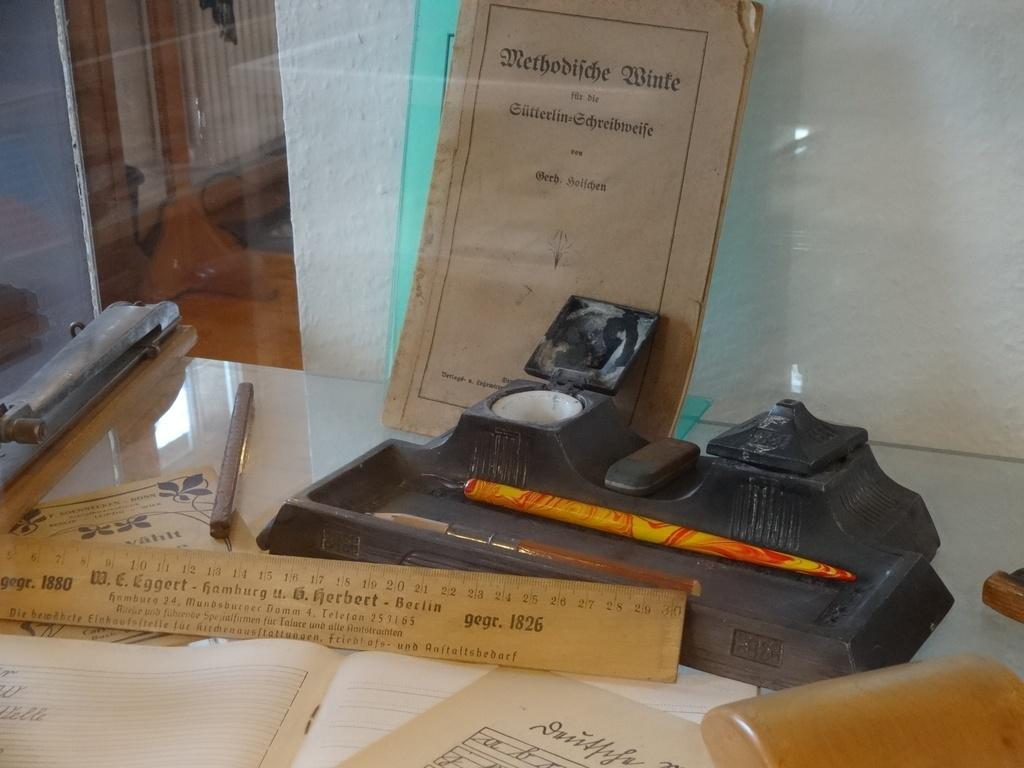<image>
Present a compact description of the photo's key features. A ruler and other items that read W.E. Eggert Hamburg. 